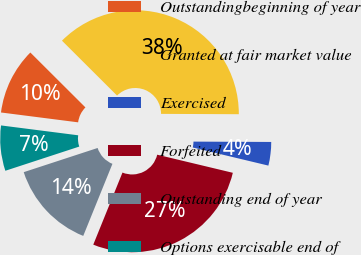<chart> <loc_0><loc_0><loc_500><loc_500><pie_chart><fcel>Outstandingbeginning of year<fcel>Granted at fair market value<fcel>Exercised<fcel>Forfeited<fcel>Outstanding end of year<fcel>Options exercisable end of<nl><fcel>10.45%<fcel>37.6%<fcel>3.67%<fcel>27.39%<fcel>13.84%<fcel>7.06%<nl></chart> 